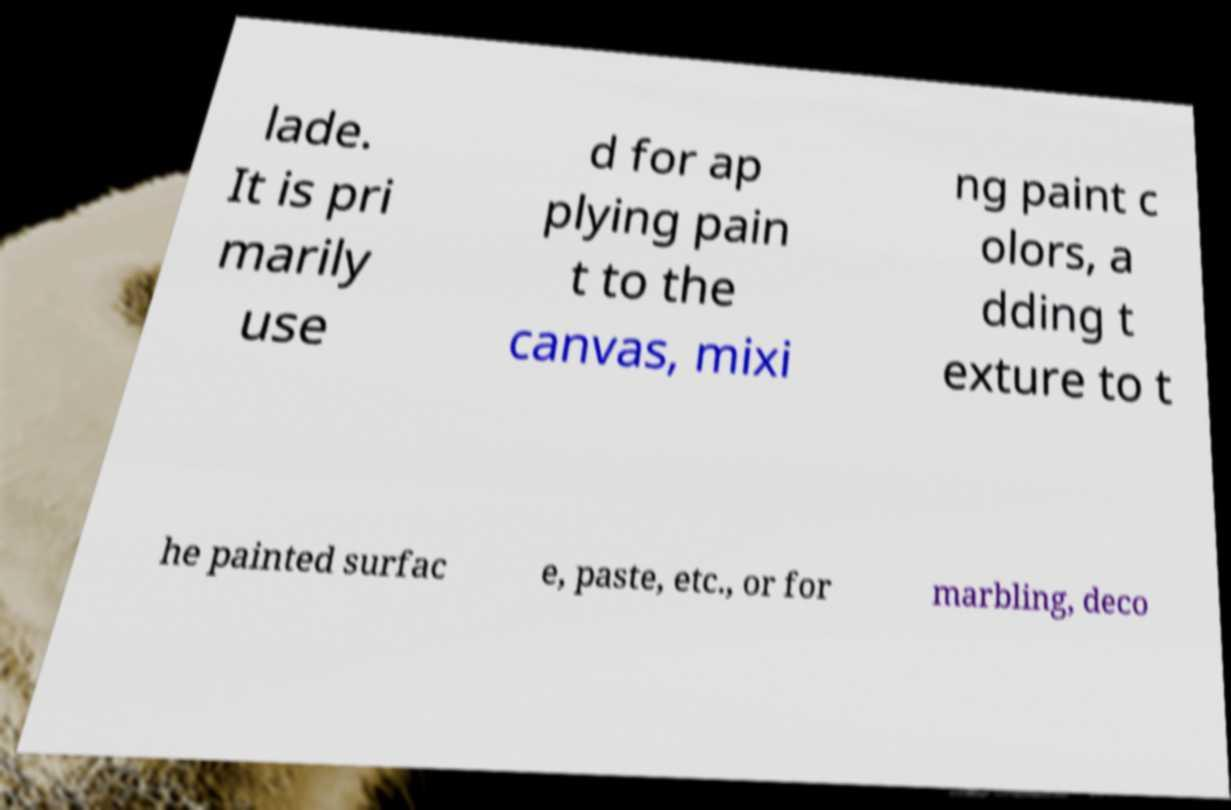There's text embedded in this image that I need extracted. Can you transcribe it verbatim? lade. It is pri marily use d for ap plying pain t to the canvas, mixi ng paint c olors, a dding t exture to t he painted surfac e, paste, etc., or for marbling, deco 